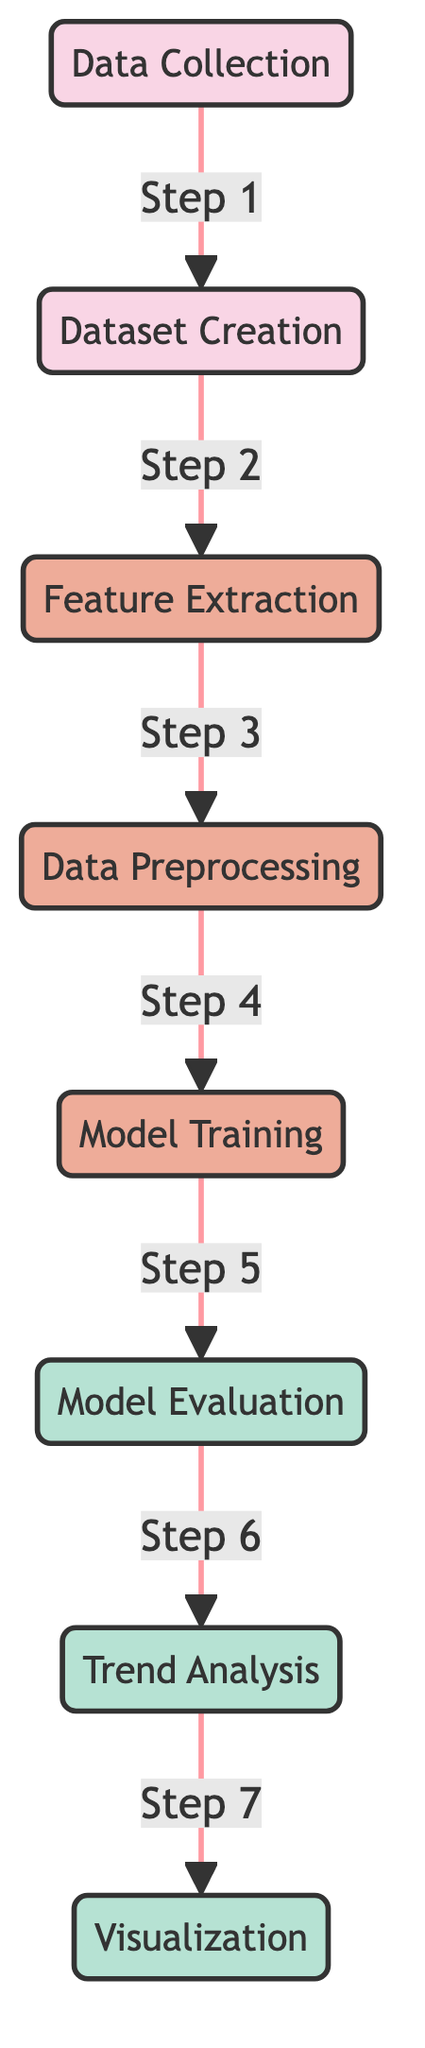What is the first step in the diagram? The first step shown in the diagram is "Data Collection," which is the starting point of the entire process.
Answer: Data Collection How many main processes are depicted in the diagram? There are six main processes depicted in the diagram, which include dataset creation, feature extraction, preprocessing, model training, model evaluation, and trend analysis.
Answer: Six What leads to model evaluation in the diagram? The step leading to model evaluation is "Model Training," which must be completed before evaluation can occur.
Answer: Model Training Which node follows trend analysis in the flow? The node that follows trend analysis in the flow is "Visualization," indicating that after analyzing trends, the results are visualized for presentation or further interpretation.
Answer: Visualization What kind of nodes are feature extraction and preprocessing? Both "Feature Extraction" and "Data Preprocessing" are categorized as process nodes, as they are steps undertaken to prepare or refine data for analysis and modeling.
Answer: Process Nodes How does data preprocessing connect to subsequent steps in the diagram? Data preprocessing connects to model training as the next step, meaning that once preprocessing is complete, the data is ready for modeling and training.
Answer: Model Training What color represents the analysis nodes in the diagram? The analysis nodes in the diagram are represented by the color green (specifically, a light green shade), which visually distinguishes them from other types of nodes.
Answer: Green Which step requires the output of the model evaluation? The step that requires the output of the model evaluation is "Trend Analysis," indicating that evaluation results are essential for understanding trends in the data.
Answer: Trend Analysis What is the final stage of the process as per the diagram? The final stage of the process, according to the diagram, is "Visualization," where the analysis results are graphically represented.
Answer: Visualization 